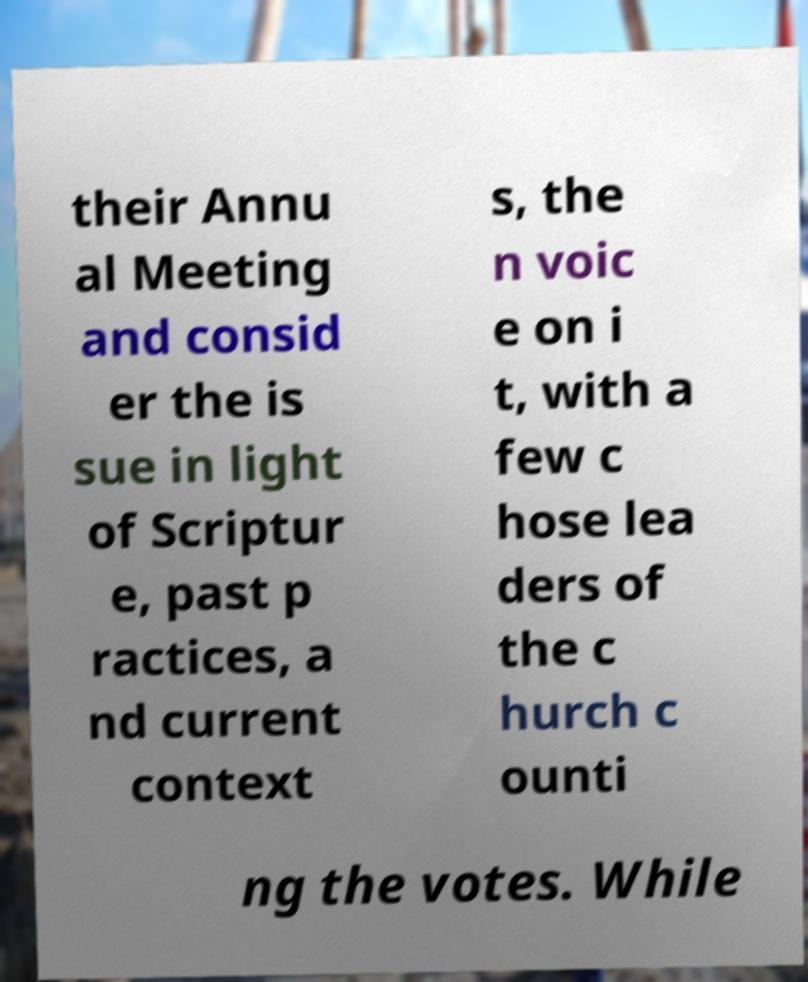Can you accurately transcribe the text from the provided image for me? their Annu al Meeting and consid er the is sue in light of Scriptur e, past p ractices, a nd current context s, the n voic e on i t, with a few c hose lea ders of the c hurch c ounti ng the votes. While 